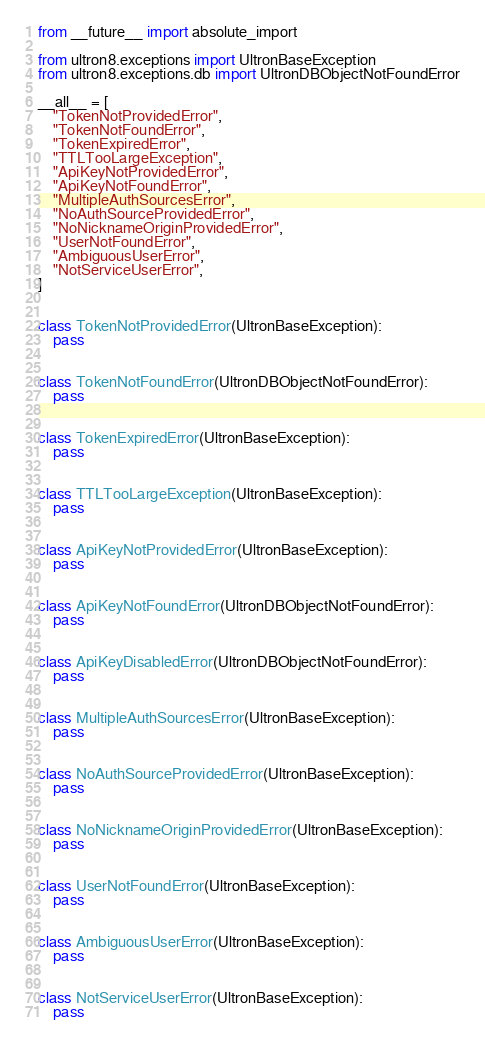Convert code to text. <code><loc_0><loc_0><loc_500><loc_500><_Python_>from __future__ import absolute_import

from ultron8.exceptions import UltronBaseException
from ultron8.exceptions.db import UltronDBObjectNotFoundError

__all__ = [
    "TokenNotProvidedError",
    "TokenNotFoundError",
    "TokenExpiredError",
    "TTLTooLargeException",
    "ApiKeyNotProvidedError",
    "ApiKeyNotFoundError",
    "MultipleAuthSourcesError",
    "NoAuthSourceProvidedError",
    "NoNicknameOriginProvidedError",
    "UserNotFoundError",
    "AmbiguousUserError",
    "NotServiceUserError",
]


class TokenNotProvidedError(UltronBaseException):
    pass


class TokenNotFoundError(UltronDBObjectNotFoundError):
    pass


class TokenExpiredError(UltronBaseException):
    pass


class TTLTooLargeException(UltronBaseException):
    pass


class ApiKeyNotProvidedError(UltronBaseException):
    pass


class ApiKeyNotFoundError(UltronDBObjectNotFoundError):
    pass


class ApiKeyDisabledError(UltronDBObjectNotFoundError):
    pass


class MultipleAuthSourcesError(UltronBaseException):
    pass


class NoAuthSourceProvidedError(UltronBaseException):
    pass


class NoNicknameOriginProvidedError(UltronBaseException):
    pass


class UserNotFoundError(UltronBaseException):
    pass


class AmbiguousUserError(UltronBaseException):
    pass


class NotServiceUserError(UltronBaseException):
    pass
</code> 